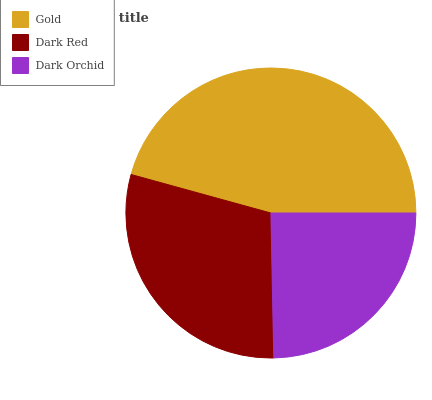Is Dark Orchid the minimum?
Answer yes or no. Yes. Is Gold the maximum?
Answer yes or no. Yes. Is Dark Red the minimum?
Answer yes or no. No. Is Dark Red the maximum?
Answer yes or no. No. Is Gold greater than Dark Red?
Answer yes or no. Yes. Is Dark Red less than Gold?
Answer yes or no. Yes. Is Dark Red greater than Gold?
Answer yes or no. No. Is Gold less than Dark Red?
Answer yes or no. No. Is Dark Red the high median?
Answer yes or no. Yes. Is Dark Red the low median?
Answer yes or no. Yes. Is Gold the high median?
Answer yes or no. No. Is Dark Orchid the low median?
Answer yes or no. No. 